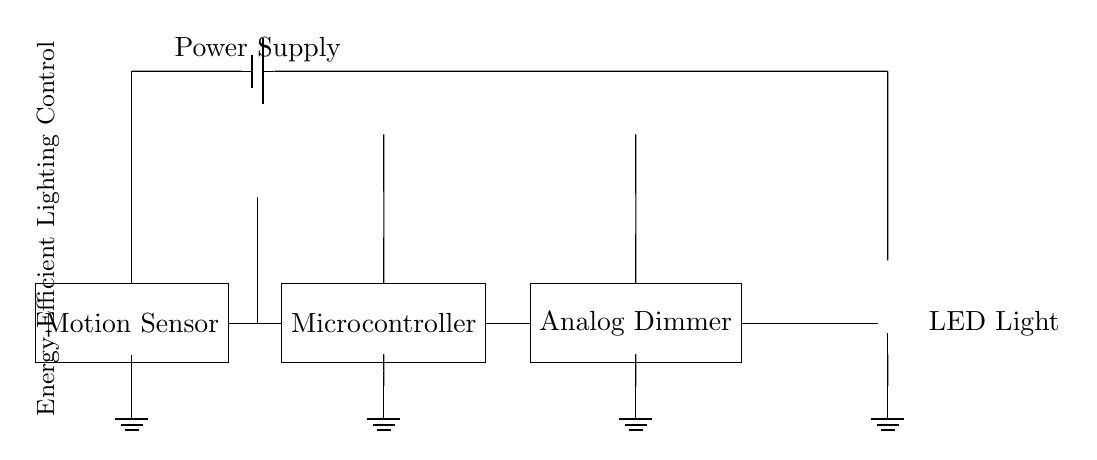What component detects motion in the circuit? The motion sensor is the component that detects motion, as indicated in the diagram.
Answer: Motion Sensor How many main components are there in this circuit? The diagram shows four main components: motion sensor, microcontroller, analog dimmer, and LED light.
Answer: Four What is the function of the microcontroller in this circuit? The microcontroller processes the input from the motion sensor and controls the dimming level of the lighting according to that input.
Answer: Control dimming What type of lighting is used in this circuit? The circuit utilizes LED light as indicated in the circuit diagram.
Answer: LED Light What is the purpose of the analog dimmer? The analog dimmer adjusts the brightness of the LED light based on the signals received from the microcontroller.
Answer: Adjust brightness What connects the power supply to the motion sensor? The power supply is connected to the motion sensor through a wire that supplies voltage to power it.
Answer: Wire Why is a digital sensor used in this circuit instead of an analog one? Using a digital sensor allows for better reliability and precision in detecting motion, which is crucial for energy efficiency in lighting control.
Answer: Energy efficiency 